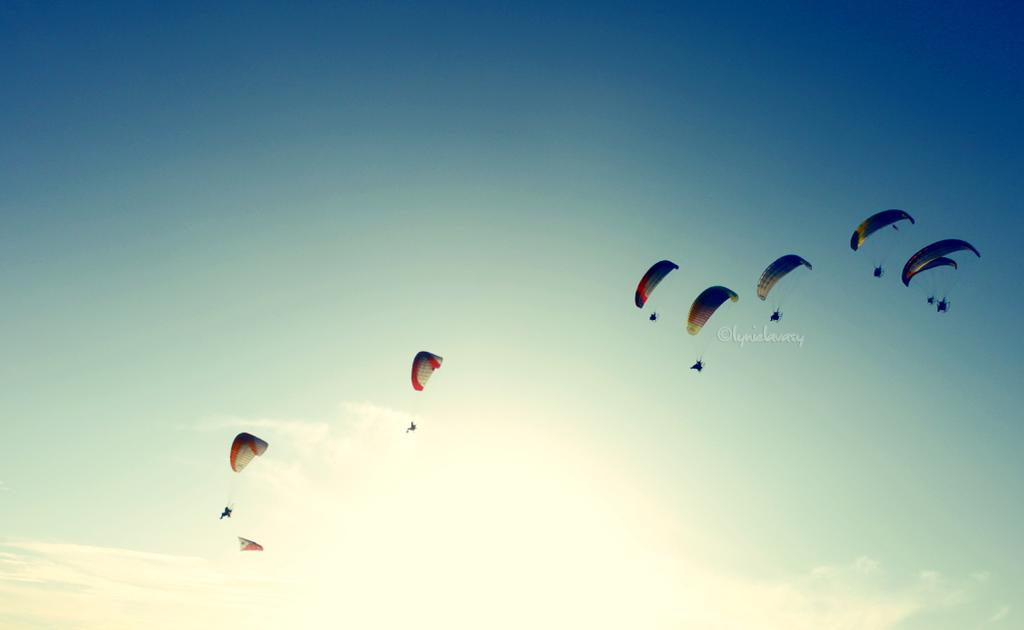What objects are present in the picture? There are parachutes in the picture. How would you describe the sky in the image? The sky is blue and cloudy. Can you see a gold sail in the picture? There is no sail, gold or otherwise, present in the image. The image features parachutes and a blue, cloudy sky. 